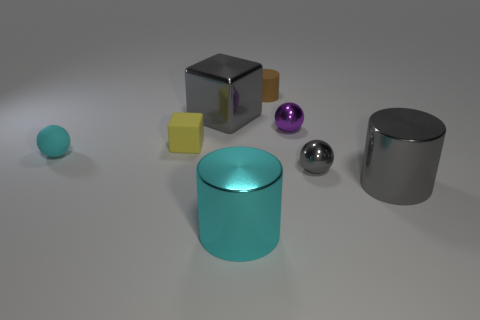Add 1 large cyan metal cylinders. How many objects exist? 9 Subtract all cylinders. How many objects are left? 5 Add 6 big purple metallic objects. How many big purple metallic objects exist? 6 Subtract 0 purple cubes. How many objects are left? 8 Subtract all large things. Subtract all tiny gray spheres. How many objects are left? 4 Add 4 big gray cylinders. How many big gray cylinders are left? 5 